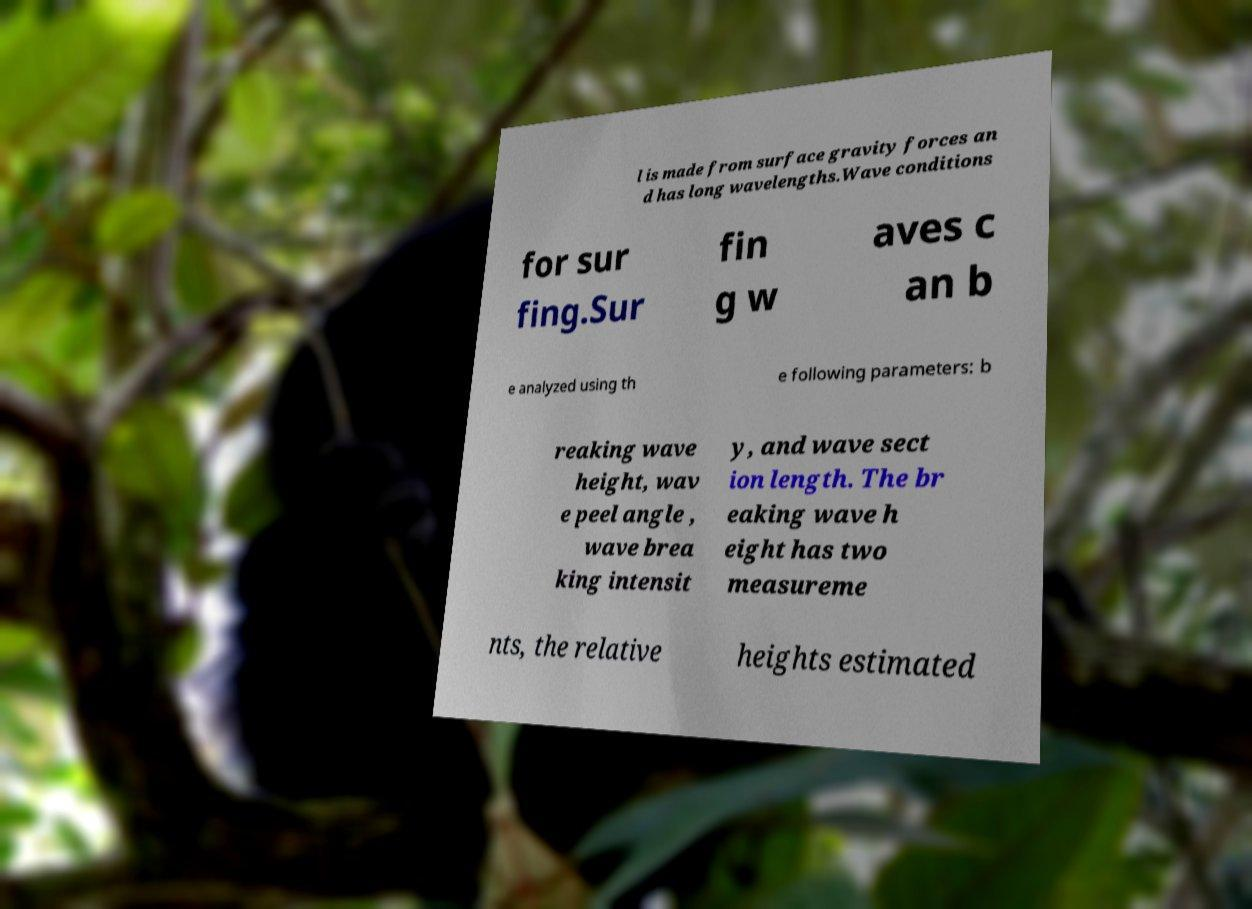There's text embedded in this image that I need extracted. Can you transcribe it verbatim? l is made from surface gravity forces an d has long wavelengths.Wave conditions for sur fing.Sur fin g w aves c an b e analyzed using th e following parameters: b reaking wave height, wav e peel angle , wave brea king intensit y, and wave sect ion length. The br eaking wave h eight has two measureme nts, the relative heights estimated 